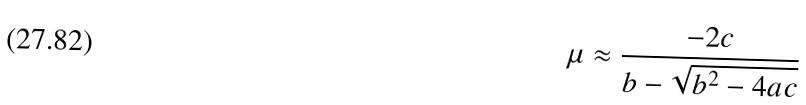Convert formula to latex. <formula><loc_0><loc_0><loc_500><loc_500>\mu \approx \frac { - 2 c } { b - \sqrt { b ^ { 2 } - 4 a c } }</formula> 